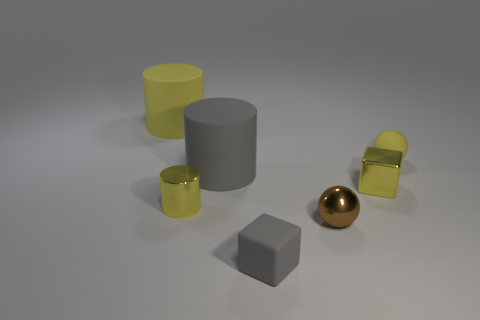How many things are either yellow matte things to the right of the tiny metallic cylinder or small objects that are behind the gray block?
Ensure brevity in your answer.  4. How many other things are there of the same color as the small shiny sphere?
Provide a short and direct response. 0. Are there fewer yellow metallic cylinders that are behind the yellow metal cylinder than small metallic balls on the left side of the shiny ball?
Your answer should be very brief. No. What number of tiny cylinders are there?
Provide a short and direct response. 1. Is there anything else that has the same material as the tiny cylinder?
Offer a very short reply. Yes. There is another object that is the same shape as the tiny gray matte object; what is it made of?
Your answer should be very brief. Metal. Are there fewer rubber blocks behind the large yellow rubber cylinder than large blue balls?
Make the answer very short. No. Do the gray object in front of the yellow block and the brown thing have the same shape?
Ensure brevity in your answer.  No. Is there anything else that is the same color as the tiny shiny cylinder?
Make the answer very short. Yes. There is a yellow object that is made of the same material as the small yellow ball; what is its size?
Give a very brief answer. Large. 